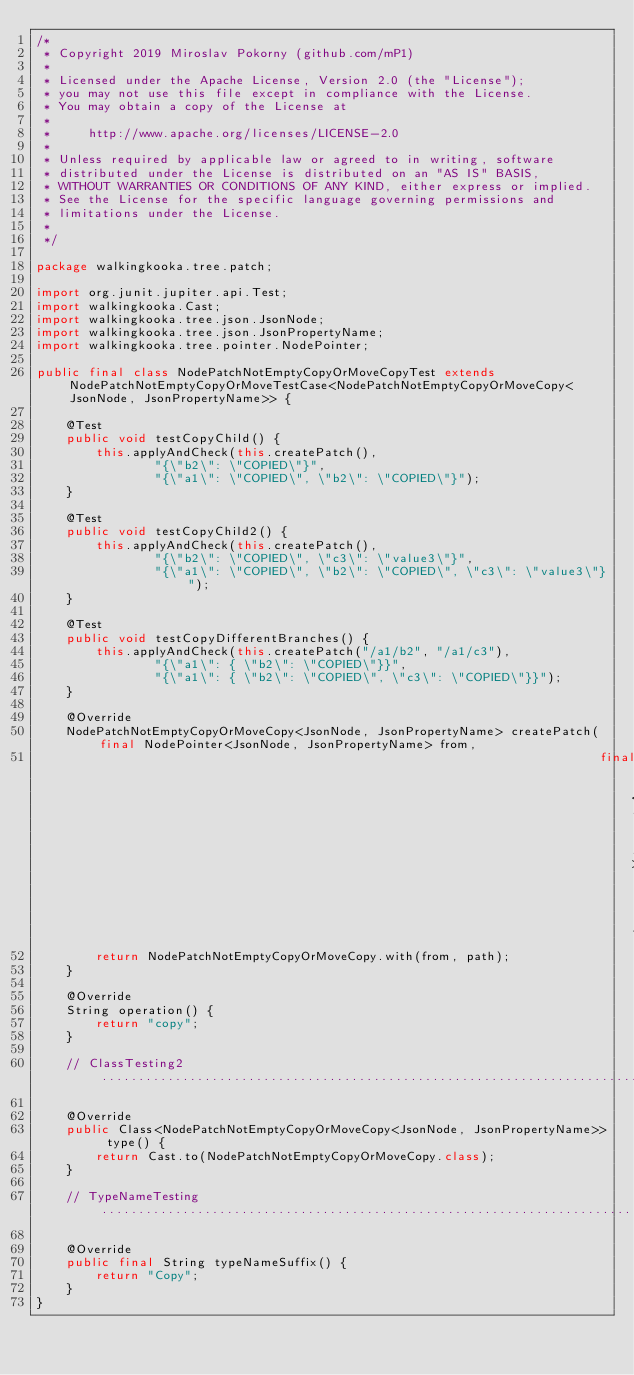Convert code to text. <code><loc_0><loc_0><loc_500><loc_500><_Java_>/*
 * Copyright 2019 Miroslav Pokorny (github.com/mP1)
 *
 * Licensed under the Apache License, Version 2.0 (the "License");
 * you may not use this file except in compliance with the License.
 * You may obtain a copy of the License at
 *
 *     http://www.apache.org/licenses/LICENSE-2.0
 *
 * Unless required by applicable law or agreed to in writing, software
 * distributed under the License is distributed on an "AS IS" BASIS,
 * WITHOUT WARRANTIES OR CONDITIONS OF ANY KIND, either express or implied.
 * See the License for the specific language governing permissions and
 * limitations under the License.
 *
 */

package walkingkooka.tree.patch;

import org.junit.jupiter.api.Test;
import walkingkooka.Cast;
import walkingkooka.tree.json.JsonNode;
import walkingkooka.tree.json.JsonPropertyName;
import walkingkooka.tree.pointer.NodePointer;

public final class NodePatchNotEmptyCopyOrMoveCopyTest extends NodePatchNotEmptyCopyOrMoveTestCase<NodePatchNotEmptyCopyOrMoveCopy<JsonNode, JsonPropertyName>> {

    @Test
    public void testCopyChild() {
        this.applyAndCheck(this.createPatch(),
                "{\"b2\": \"COPIED\"}",
                "{\"a1\": \"COPIED\", \"b2\": \"COPIED\"}");
    }

    @Test
    public void testCopyChild2() {
        this.applyAndCheck(this.createPatch(),
                "{\"b2\": \"COPIED\", \"c3\": \"value3\"}",
                "{\"a1\": \"COPIED\", \"b2\": \"COPIED\", \"c3\": \"value3\"}");
    }

    @Test
    public void testCopyDifferentBranches() {
        this.applyAndCheck(this.createPatch("/a1/b2", "/a1/c3"),
                "{\"a1\": { \"b2\": \"COPIED\"}}",
                "{\"a1\": { \"b2\": \"COPIED\", \"c3\": \"COPIED\"}}");
    }

    @Override
    NodePatchNotEmptyCopyOrMoveCopy<JsonNode, JsonPropertyName> createPatch(final NodePointer<JsonNode, JsonPropertyName> from,
                                                                            final NodePointer<JsonNode, JsonPropertyName> path) {
        return NodePatchNotEmptyCopyOrMoveCopy.with(from, path);
    }

    @Override
    String operation() {
        return "copy";
    }

    // ClassTesting2............................................................................

    @Override
    public Class<NodePatchNotEmptyCopyOrMoveCopy<JsonNode, JsonPropertyName>> type() {
        return Cast.to(NodePatchNotEmptyCopyOrMoveCopy.class);
    }

    // TypeNameTesting..................................................................................................

    @Override
    public final String typeNameSuffix() {
        return "Copy";
    }
}
</code> 